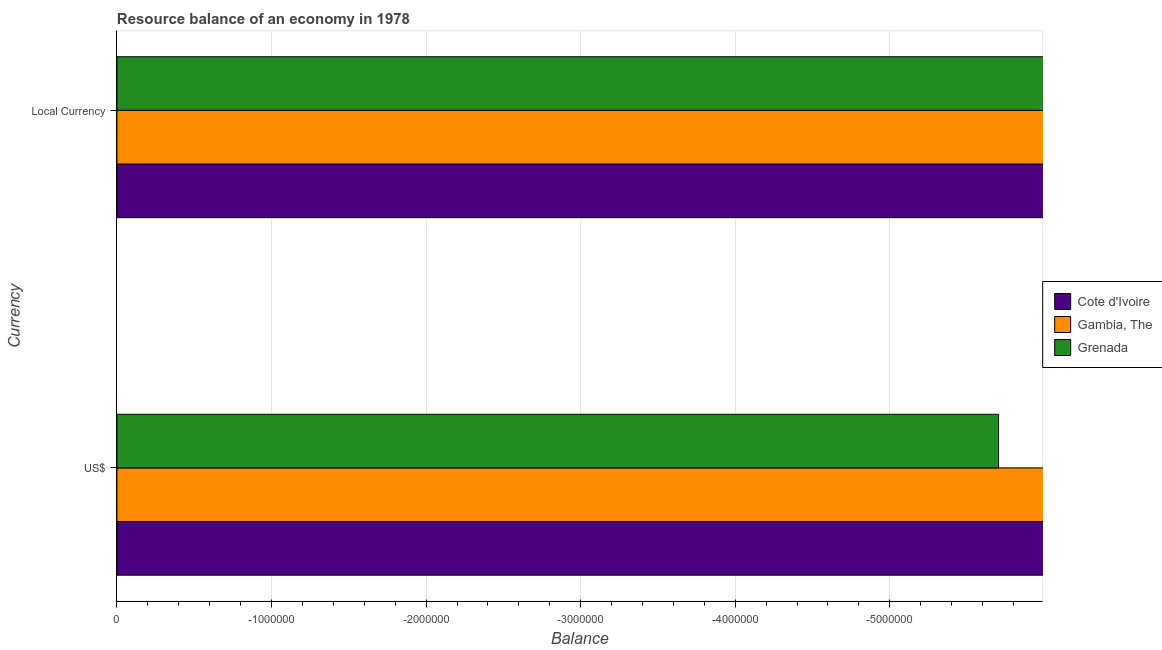Are the number of bars per tick equal to the number of legend labels?
Keep it short and to the point. No. How many bars are there on the 1st tick from the top?
Ensure brevity in your answer.  0. What is the label of the 2nd group of bars from the top?
Your answer should be compact. US$. What is the difference between the resource balance in us$ in Cote d'Ivoire and the resource balance in constant us$ in Grenada?
Your answer should be very brief. 0. In how many countries, is the resource balance in us$ greater than -1600000 units?
Provide a succinct answer. 0. How many bars are there?
Ensure brevity in your answer.  0. Are all the bars in the graph horizontal?
Make the answer very short. Yes. Are the values on the major ticks of X-axis written in scientific E-notation?
Give a very brief answer. No. Does the graph contain any zero values?
Your answer should be very brief. Yes. Where does the legend appear in the graph?
Offer a very short reply. Center right. How are the legend labels stacked?
Your response must be concise. Vertical. What is the title of the graph?
Your answer should be very brief. Resource balance of an economy in 1978. What is the label or title of the X-axis?
Provide a succinct answer. Balance. What is the label or title of the Y-axis?
Offer a very short reply. Currency. What is the Balance of Grenada in Local Currency?
Provide a short and direct response. 0. What is the total Balance of Cote d'Ivoire in the graph?
Provide a succinct answer. 0. What is the total Balance of Grenada in the graph?
Provide a short and direct response. 0. What is the average Balance of Cote d'Ivoire per Currency?
Offer a very short reply. 0. What is the average Balance of Grenada per Currency?
Your answer should be very brief. 0. 